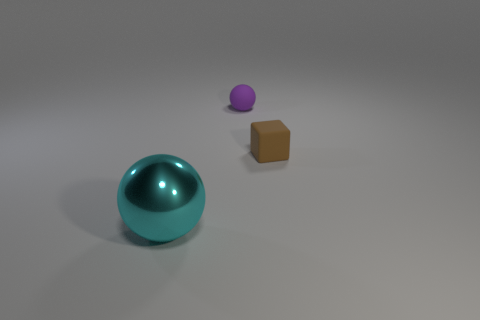Add 1 blue cylinders. How many objects exist? 4 Subtract all balls. How many objects are left? 1 Add 3 purple things. How many purple things exist? 4 Subtract 0 green cubes. How many objects are left? 3 Subtract all matte blocks. Subtract all gray shiny objects. How many objects are left? 2 Add 1 cyan shiny spheres. How many cyan shiny spheres are left? 2 